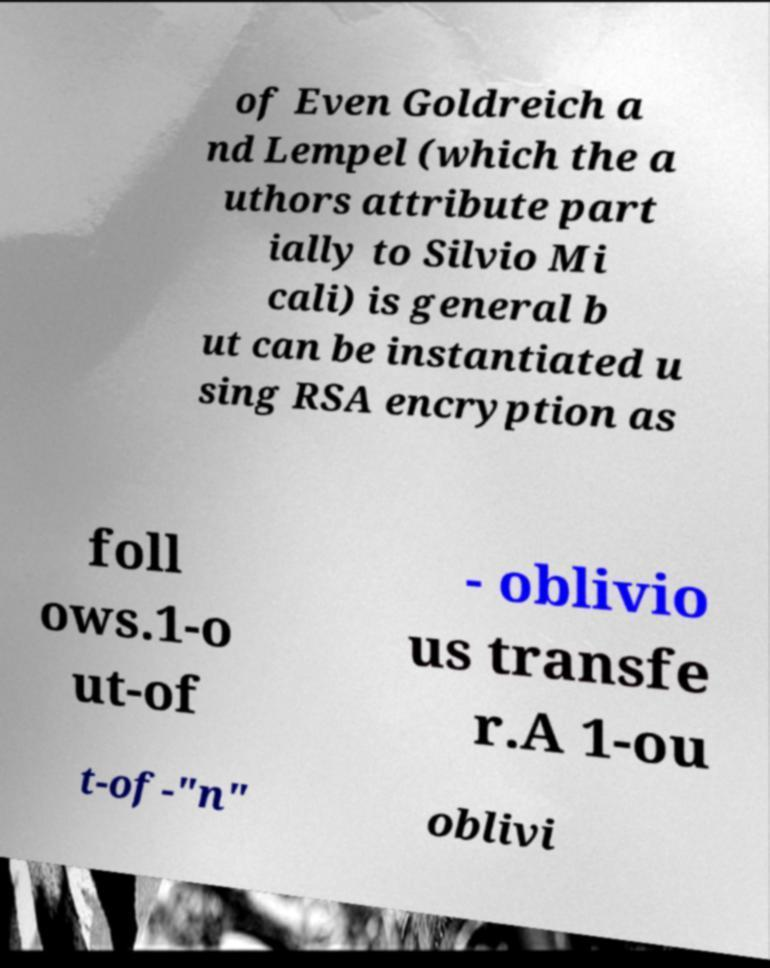I need the written content from this picture converted into text. Can you do that? of Even Goldreich a nd Lempel (which the a uthors attribute part ially to Silvio Mi cali) is general b ut can be instantiated u sing RSA encryption as foll ows.1-o ut-of - oblivio us transfe r.A 1-ou t-of-"n" oblivi 